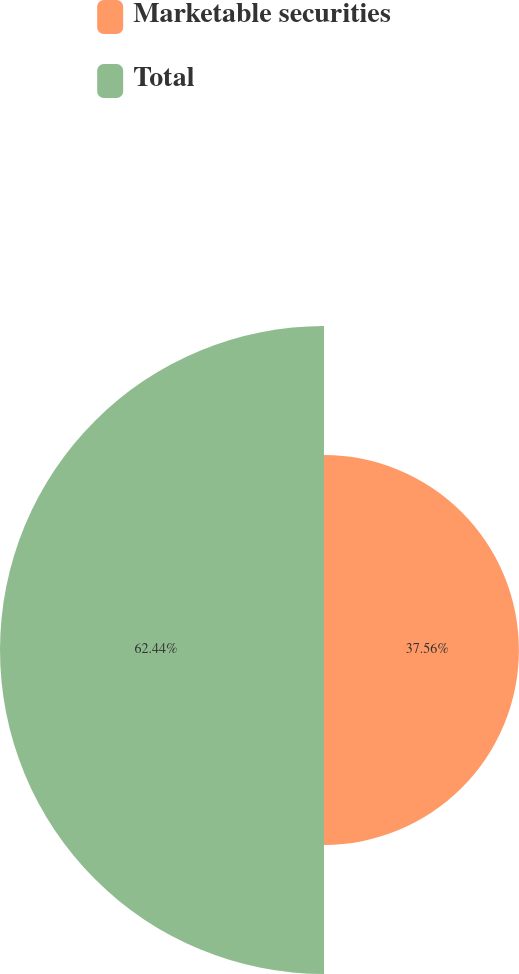<chart> <loc_0><loc_0><loc_500><loc_500><pie_chart><fcel>Marketable securities<fcel>Total<nl><fcel>37.56%<fcel>62.44%<nl></chart> 